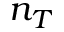Convert formula to latex. <formula><loc_0><loc_0><loc_500><loc_500>n _ { T }</formula> 